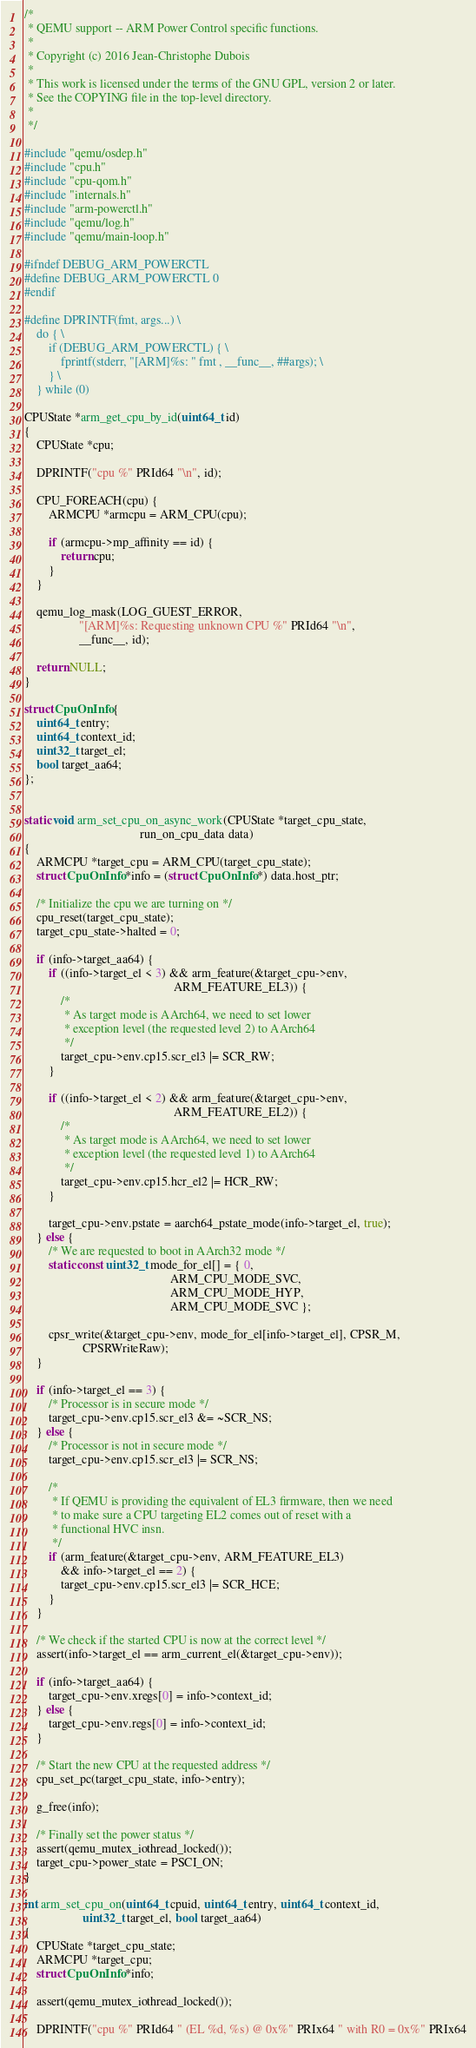<code> <loc_0><loc_0><loc_500><loc_500><_C_>/*
 * QEMU support -- ARM Power Control specific functions.
 *
 * Copyright (c) 2016 Jean-Christophe Dubois
 *
 * This work is licensed under the terms of the GNU GPL, version 2 or later.
 * See the COPYING file in the top-level directory.
 *
 */

#include "qemu/osdep.h"
#include "cpu.h"
#include "cpu-qom.h"
#include "internals.h"
#include "arm-powerctl.h"
#include "qemu/log.h"
#include "qemu/main-loop.h"

#ifndef DEBUG_ARM_POWERCTL
#define DEBUG_ARM_POWERCTL 0
#endif

#define DPRINTF(fmt, args...) \
    do { \
        if (DEBUG_ARM_POWERCTL) { \
            fprintf(stderr, "[ARM]%s: " fmt , __func__, ##args); \
        } \
    } while (0)

CPUState *arm_get_cpu_by_id(uint64_t id)
{
    CPUState *cpu;

    DPRINTF("cpu %" PRId64 "\n", id);

    CPU_FOREACH(cpu) {
        ARMCPU *armcpu = ARM_CPU(cpu);

        if (armcpu->mp_affinity == id) {
            return cpu;
        }
    }

    qemu_log_mask(LOG_GUEST_ERROR,
                  "[ARM]%s: Requesting unknown CPU %" PRId64 "\n",
                  __func__, id);

    return NULL;
}

struct CpuOnInfo {
    uint64_t entry;
    uint64_t context_id;
    uint32_t target_el;
    bool target_aa64;
};


static void arm_set_cpu_on_async_work(CPUState *target_cpu_state,
                                      run_on_cpu_data data)
{
    ARMCPU *target_cpu = ARM_CPU(target_cpu_state);
    struct CpuOnInfo *info = (struct CpuOnInfo *) data.host_ptr;

    /* Initialize the cpu we are turning on */
    cpu_reset(target_cpu_state);
    target_cpu_state->halted = 0;

    if (info->target_aa64) {
        if ((info->target_el < 3) && arm_feature(&target_cpu->env,
                                                 ARM_FEATURE_EL3)) {
            /*
             * As target mode is AArch64, we need to set lower
             * exception level (the requested level 2) to AArch64
             */
            target_cpu->env.cp15.scr_el3 |= SCR_RW;
        }

        if ((info->target_el < 2) && arm_feature(&target_cpu->env,
                                                 ARM_FEATURE_EL2)) {
            /*
             * As target mode is AArch64, we need to set lower
             * exception level (the requested level 1) to AArch64
             */
            target_cpu->env.cp15.hcr_el2 |= HCR_RW;
        }

        target_cpu->env.pstate = aarch64_pstate_mode(info->target_el, true);
    } else {
        /* We are requested to boot in AArch32 mode */
        static const uint32_t mode_for_el[] = { 0,
                                                ARM_CPU_MODE_SVC,
                                                ARM_CPU_MODE_HYP,
                                                ARM_CPU_MODE_SVC };

        cpsr_write(&target_cpu->env, mode_for_el[info->target_el], CPSR_M,
                   CPSRWriteRaw);
    }

    if (info->target_el == 3) {
        /* Processor is in secure mode */
        target_cpu->env.cp15.scr_el3 &= ~SCR_NS;
    } else {
        /* Processor is not in secure mode */
        target_cpu->env.cp15.scr_el3 |= SCR_NS;

        /*
         * If QEMU is providing the equivalent of EL3 firmware, then we need
         * to make sure a CPU targeting EL2 comes out of reset with a
         * functional HVC insn.
         */
        if (arm_feature(&target_cpu->env, ARM_FEATURE_EL3)
            && info->target_el == 2) {
            target_cpu->env.cp15.scr_el3 |= SCR_HCE;
        }
    }

    /* We check if the started CPU is now at the correct level */
    assert(info->target_el == arm_current_el(&target_cpu->env));

    if (info->target_aa64) {
        target_cpu->env.xregs[0] = info->context_id;
    } else {
        target_cpu->env.regs[0] = info->context_id;
    }

    /* Start the new CPU at the requested address */
    cpu_set_pc(target_cpu_state, info->entry);

    g_free(info);

    /* Finally set the power status */
    assert(qemu_mutex_iothread_locked());
    target_cpu->power_state = PSCI_ON;
}

int arm_set_cpu_on(uint64_t cpuid, uint64_t entry, uint64_t context_id,
                   uint32_t target_el, bool target_aa64)
{
    CPUState *target_cpu_state;
    ARMCPU *target_cpu;
    struct CpuOnInfo *info;

    assert(qemu_mutex_iothread_locked());

    DPRINTF("cpu %" PRId64 " (EL %d, %s) @ 0x%" PRIx64 " with R0 = 0x%" PRIx64</code> 